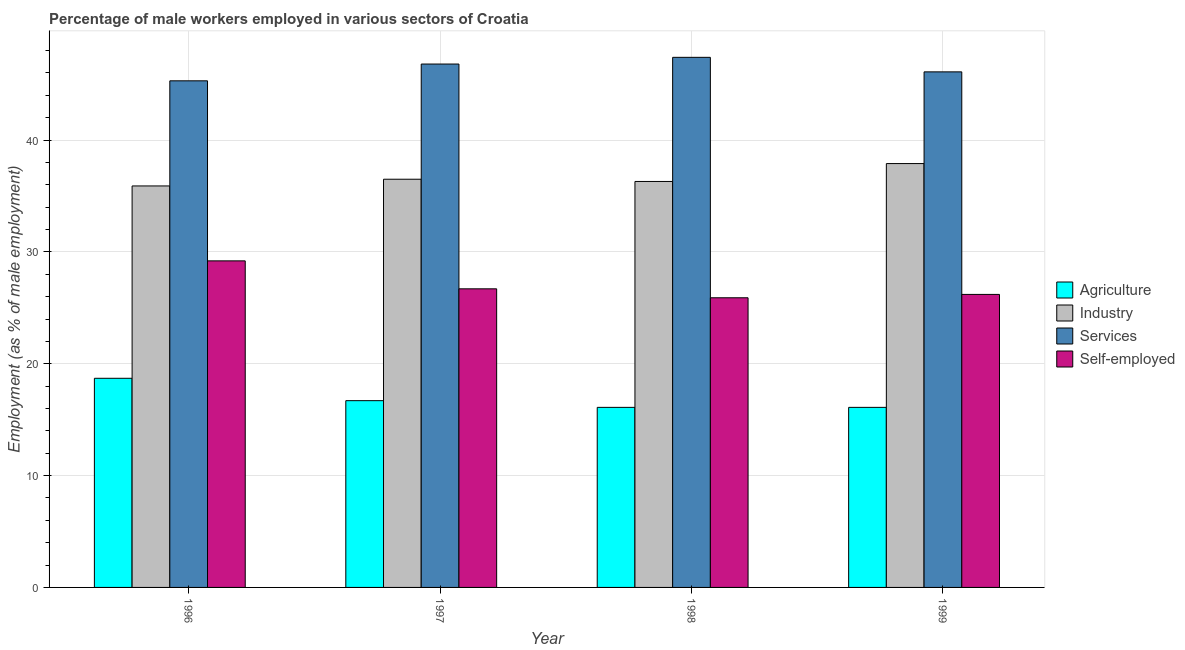How many groups of bars are there?
Your response must be concise. 4. Are the number of bars per tick equal to the number of legend labels?
Offer a very short reply. Yes. Are the number of bars on each tick of the X-axis equal?
Offer a terse response. Yes. How many bars are there on the 1st tick from the right?
Provide a short and direct response. 4. What is the percentage of male workers in services in 1999?
Make the answer very short. 46.1. Across all years, what is the maximum percentage of male workers in industry?
Offer a very short reply. 37.9. Across all years, what is the minimum percentage of male workers in agriculture?
Offer a terse response. 16.1. In which year was the percentage of male workers in agriculture maximum?
Ensure brevity in your answer.  1996. What is the total percentage of male workers in agriculture in the graph?
Ensure brevity in your answer.  67.6. What is the difference between the percentage of self employed male workers in 1998 and the percentage of male workers in agriculture in 1999?
Your answer should be very brief. -0.3. What is the average percentage of male workers in services per year?
Offer a terse response. 46.4. In the year 1998, what is the difference between the percentage of male workers in services and percentage of self employed male workers?
Your answer should be compact. 0. What is the ratio of the percentage of self employed male workers in 1998 to that in 1999?
Offer a very short reply. 0.99. Is the difference between the percentage of self employed male workers in 1998 and 1999 greater than the difference between the percentage of male workers in industry in 1998 and 1999?
Give a very brief answer. No. What is the difference between the highest and the second highest percentage of male workers in industry?
Your answer should be compact. 1.4. What is the difference between the highest and the lowest percentage of male workers in agriculture?
Your response must be concise. 2.6. Is the sum of the percentage of male workers in agriculture in 1997 and 1999 greater than the maximum percentage of male workers in services across all years?
Ensure brevity in your answer.  Yes. Is it the case that in every year, the sum of the percentage of male workers in services and percentage of male workers in agriculture is greater than the sum of percentage of self employed male workers and percentage of male workers in industry?
Your response must be concise. Yes. What does the 2nd bar from the left in 1997 represents?
Your response must be concise. Industry. What does the 4th bar from the right in 1998 represents?
Keep it short and to the point. Agriculture. Is it the case that in every year, the sum of the percentage of male workers in agriculture and percentage of male workers in industry is greater than the percentage of male workers in services?
Provide a succinct answer. Yes. How many years are there in the graph?
Provide a short and direct response. 4. What is the difference between two consecutive major ticks on the Y-axis?
Offer a very short reply. 10. Does the graph contain any zero values?
Give a very brief answer. No. How many legend labels are there?
Ensure brevity in your answer.  4. What is the title of the graph?
Offer a very short reply. Percentage of male workers employed in various sectors of Croatia. What is the label or title of the X-axis?
Keep it short and to the point. Year. What is the label or title of the Y-axis?
Provide a succinct answer. Employment (as % of male employment). What is the Employment (as % of male employment) in Agriculture in 1996?
Give a very brief answer. 18.7. What is the Employment (as % of male employment) of Industry in 1996?
Provide a short and direct response. 35.9. What is the Employment (as % of male employment) of Services in 1996?
Ensure brevity in your answer.  45.3. What is the Employment (as % of male employment) of Self-employed in 1996?
Your response must be concise. 29.2. What is the Employment (as % of male employment) in Agriculture in 1997?
Ensure brevity in your answer.  16.7. What is the Employment (as % of male employment) of Industry in 1997?
Your answer should be very brief. 36.5. What is the Employment (as % of male employment) in Services in 1997?
Give a very brief answer. 46.8. What is the Employment (as % of male employment) in Self-employed in 1997?
Offer a terse response. 26.7. What is the Employment (as % of male employment) of Agriculture in 1998?
Keep it short and to the point. 16.1. What is the Employment (as % of male employment) of Industry in 1998?
Provide a succinct answer. 36.3. What is the Employment (as % of male employment) in Services in 1998?
Offer a very short reply. 47.4. What is the Employment (as % of male employment) in Self-employed in 1998?
Your response must be concise. 25.9. What is the Employment (as % of male employment) in Agriculture in 1999?
Offer a very short reply. 16.1. What is the Employment (as % of male employment) in Industry in 1999?
Give a very brief answer. 37.9. What is the Employment (as % of male employment) in Services in 1999?
Give a very brief answer. 46.1. What is the Employment (as % of male employment) in Self-employed in 1999?
Your answer should be compact. 26.2. Across all years, what is the maximum Employment (as % of male employment) in Agriculture?
Your answer should be very brief. 18.7. Across all years, what is the maximum Employment (as % of male employment) in Industry?
Offer a very short reply. 37.9. Across all years, what is the maximum Employment (as % of male employment) of Services?
Provide a succinct answer. 47.4. Across all years, what is the maximum Employment (as % of male employment) of Self-employed?
Ensure brevity in your answer.  29.2. Across all years, what is the minimum Employment (as % of male employment) in Agriculture?
Your response must be concise. 16.1. Across all years, what is the minimum Employment (as % of male employment) in Industry?
Provide a succinct answer. 35.9. Across all years, what is the minimum Employment (as % of male employment) of Services?
Keep it short and to the point. 45.3. Across all years, what is the minimum Employment (as % of male employment) of Self-employed?
Keep it short and to the point. 25.9. What is the total Employment (as % of male employment) of Agriculture in the graph?
Ensure brevity in your answer.  67.6. What is the total Employment (as % of male employment) in Industry in the graph?
Make the answer very short. 146.6. What is the total Employment (as % of male employment) of Services in the graph?
Keep it short and to the point. 185.6. What is the total Employment (as % of male employment) of Self-employed in the graph?
Provide a succinct answer. 108. What is the difference between the Employment (as % of male employment) in Industry in 1996 and that in 1997?
Provide a succinct answer. -0.6. What is the difference between the Employment (as % of male employment) of Services in 1996 and that in 1997?
Provide a short and direct response. -1.5. What is the difference between the Employment (as % of male employment) of Self-employed in 1996 and that in 1997?
Provide a succinct answer. 2.5. What is the difference between the Employment (as % of male employment) in Agriculture in 1996 and that in 1999?
Give a very brief answer. 2.6. What is the difference between the Employment (as % of male employment) in Self-employed in 1996 and that in 1999?
Provide a short and direct response. 3. What is the difference between the Employment (as % of male employment) of Agriculture in 1997 and that in 1998?
Give a very brief answer. 0.6. What is the difference between the Employment (as % of male employment) of Industry in 1997 and that in 1998?
Offer a very short reply. 0.2. What is the difference between the Employment (as % of male employment) of Industry in 1997 and that in 1999?
Your response must be concise. -1.4. What is the difference between the Employment (as % of male employment) of Services in 1997 and that in 1999?
Provide a short and direct response. 0.7. What is the difference between the Employment (as % of male employment) of Agriculture in 1998 and that in 1999?
Your response must be concise. 0. What is the difference between the Employment (as % of male employment) of Industry in 1998 and that in 1999?
Make the answer very short. -1.6. What is the difference between the Employment (as % of male employment) in Agriculture in 1996 and the Employment (as % of male employment) in Industry in 1997?
Offer a very short reply. -17.8. What is the difference between the Employment (as % of male employment) in Agriculture in 1996 and the Employment (as % of male employment) in Services in 1997?
Offer a very short reply. -28.1. What is the difference between the Employment (as % of male employment) of Agriculture in 1996 and the Employment (as % of male employment) of Self-employed in 1997?
Offer a terse response. -8. What is the difference between the Employment (as % of male employment) of Industry in 1996 and the Employment (as % of male employment) of Self-employed in 1997?
Your answer should be compact. 9.2. What is the difference between the Employment (as % of male employment) in Agriculture in 1996 and the Employment (as % of male employment) in Industry in 1998?
Your response must be concise. -17.6. What is the difference between the Employment (as % of male employment) in Agriculture in 1996 and the Employment (as % of male employment) in Services in 1998?
Your answer should be compact. -28.7. What is the difference between the Employment (as % of male employment) in Agriculture in 1996 and the Employment (as % of male employment) in Self-employed in 1998?
Offer a terse response. -7.2. What is the difference between the Employment (as % of male employment) of Industry in 1996 and the Employment (as % of male employment) of Services in 1998?
Your response must be concise. -11.5. What is the difference between the Employment (as % of male employment) of Industry in 1996 and the Employment (as % of male employment) of Self-employed in 1998?
Your answer should be compact. 10. What is the difference between the Employment (as % of male employment) of Services in 1996 and the Employment (as % of male employment) of Self-employed in 1998?
Offer a very short reply. 19.4. What is the difference between the Employment (as % of male employment) of Agriculture in 1996 and the Employment (as % of male employment) of Industry in 1999?
Give a very brief answer. -19.2. What is the difference between the Employment (as % of male employment) of Agriculture in 1996 and the Employment (as % of male employment) of Services in 1999?
Ensure brevity in your answer.  -27.4. What is the difference between the Employment (as % of male employment) in Agriculture in 1996 and the Employment (as % of male employment) in Self-employed in 1999?
Provide a short and direct response. -7.5. What is the difference between the Employment (as % of male employment) of Industry in 1996 and the Employment (as % of male employment) of Services in 1999?
Your response must be concise. -10.2. What is the difference between the Employment (as % of male employment) in Services in 1996 and the Employment (as % of male employment) in Self-employed in 1999?
Your answer should be very brief. 19.1. What is the difference between the Employment (as % of male employment) in Agriculture in 1997 and the Employment (as % of male employment) in Industry in 1998?
Ensure brevity in your answer.  -19.6. What is the difference between the Employment (as % of male employment) of Agriculture in 1997 and the Employment (as % of male employment) of Services in 1998?
Offer a very short reply. -30.7. What is the difference between the Employment (as % of male employment) of Industry in 1997 and the Employment (as % of male employment) of Services in 1998?
Offer a terse response. -10.9. What is the difference between the Employment (as % of male employment) in Industry in 1997 and the Employment (as % of male employment) in Self-employed in 1998?
Your answer should be very brief. 10.6. What is the difference between the Employment (as % of male employment) of Services in 1997 and the Employment (as % of male employment) of Self-employed in 1998?
Provide a succinct answer. 20.9. What is the difference between the Employment (as % of male employment) in Agriculture in 1997 and the Employment (as % of male employment) in Industry in 1999?
Provide a short and direct response. -21.2. What is the difference between the Employment (as % of male employment) of Agriculture in 1997 and the Employment (as % of male employment) of Services in 1999?
Your response must be concise. -29.4. What is the difference between the Employment (as % of male employment) of Services in 1997 and the Employment (as % of male employment) of Self-employed in 1999?
Make the answer very short. 20.6. What is the difference between the Employment (as % of male employment) of Agriculture in 1998 and the Employment (as % of male employment) of Industry in 1999?
Your answer should be compact. -21.8. What is the difference between the Employment (as % of male employment) of Agriculture in 1998 and the Employment (as % of male employment) of Services in 1999?
Your response must be concise. -30. What is the difference between the Employment (as % of male employment) in Agriculture in 1998 and the Employment (as % of male employment) in Self-employed in 1999?
Offer a very short reply. -10.1. What is the difference between the Employment (as % of male employment) of Services in 1998 and the Employment (as % of male employment) of Self-employed in 1999?
Make the answer very short. 21.2. What is the average Employment (as % of male employment) in Industry per year?
Ensure brevity in your answer.  36.65. What is the average Employment (as % of male employment) of Services per year?
Provide a succinct answer. 46.4. What is the average Employment (as % of male employment) of Self-employed per year?
Offer a terse response. 27. In the year 1996, what is the difference between the Employment (as % of male employment) in Agriculture and Employment (as % of male employment) in Industry?
Offer a terse response. -17.2. In the year 1996, what is the difference between the Employment (as % of male employment) of Agriculture and Employment (as % of male employment) of Services?
Offer a terse response. -26.6. In the year 1996, what is the difference between the Employment (as % of male employment) of Agriculture and Employment (as % of male employment) of Self-employed?
Offer a terse response. -10.5. In the year 1996, what is the difference between the Employment (as % of male employment) in Industry and Employment (as % of male employment) in Services?
Your answer should be compact. -9.4. In the year 1997, what is the difference between the Employment (as % of male employment) of Agriculture and Employment (as % of male employment) of Industry?
Offer a very short reply. -19.8. In the year 1997, what is the difference between the Employment (as % of male employment) in Agriculture and Employment (as % of male employment) in Services?
Keep it short and to the point. -30.1. In the year 1997, what is the difference between the Employment (as % of male employment) in Agriculture and Employment (as % of male employment) in Self-employed?
Your answer should be compact. -10. In the year 1997, what is the difference between the Employment (as % of male employment) in Industry and Employment (as % of male employment) in Services?
Give a very brief answer. -10.3. In the year 1997, what is the difference between the Employment (as % of male employment) of Services and Employment (as % of male employment) of Self-employed?
Provide a short and direct response. 20.1. In the year 1998, what is the difference between the Employment (as % of male employment) of Agriculture and Employment (as % of male employment) of Industry?
Provide a short and direct response. -20.2. In the year 1998, what is the difference between the Employment (as % of male employment) in Agriculture and Employment (as % of male employment) in Services?
Give a very brief answer. -31.3. In the year 1998, what is the difference between the Employment (as % of male employment) of Industry and Employment (as % of male employment) of Services?
Provide a short and direct response. -11.1. In the year 1998, what is the difference between the Employment (as % of male employment) in Industry and Employment (as % of male employment) in Self-employed?
Make the answer very short. 10.4. In the year 1998, what is the difference between the Employment (as % of male employment) in Services and Employment (as % of male employment) in Self-employed?
Your answer should be very brief. 21.5. In the year 1999, what is the difference between the Employment (as % of male employment) of Agriculture and Employment (as % of male employment) of Industry?
Give a very brief answer. -21.8. In the year 1999, what is the difference between the Employment (as % of male employment) of Agriculture and Employment (as % of male employment) of Services?
Provide a succinct answer. -30. In the year 1999, what is the difference between the Employment (as % of male employment) in Industry and Employment (as % of male employment) in Services?
Ensure brevity in your answer.  -8.2. In the year 1999, what is the difference between the Employment (as % of male employment) of Industry and Employment (as % of male employment) of Self-employed?
Offer a very short reply. 11.7. What is the ratio of the Employment (as % of male employment) in Agriculture in 1996 to that in 1997?
Ensure brevity in your answer.  1.12. What is the ratio of the Employment (as % of male employment) in Industry in 1996 to that in 1997?
Your response must be concise. 0.98. What is the ratio of the Employment (as % of male employment) in Services in 1996 to that in 1997?
Provide a succinct answer. 0.97. What is the ratio of the Employment (as % of male employment) of Self-employed in 1996 to that in 1997?
Provide a short and direct response. 1.09. What is the ratio of the Employment (as % of male employment) of Agriculture in 1996 to that in 1998?
Offer a very short reply. 1.16. What is the ratio of the Employment (as % of male employment) in Industry in 1996 to that in 1998?
Make the answer very short. 0.99. What is the ratio of the Employment (as % of male employment) in Services in 1996 to that in 1998?
Keep it short and to the point. 0.96. What is the ratio of the Employment (as % of male employment) in Self-employed in 1996 to that in 1998?
Offer a very short reply. 1.13. What is the ratio of the Employment (as % of male employment) in Agriculture in 1996 to that in 1999?
Your response must be concise. 1.16. What is the ratio of the Employment (as % of male employment) in Industry in 1996 to that in 1999?
Give a very brief answer. 0.95. What is the ratio of the Employment (as % of male employment) in Services in 1996 to that in 1999?
Your answer should be compact. 0.98. What is the ratio of the Employment (as % of male employment) of Self-employed in 1996 to that in 1999?
Offer a very short reply. 1.11. What is the ratio of the Employment (as % of male employment) of Agriculture in 1997 to that in 1998?
Provide a succinct answer. 1.04. What is the ratio of the Employment (as % of male employment) in Services in 1997 to that in 1998?
Your answer should be very brief. 0.99. What is the ratio of the Employment (as % of male employment) in Self-employed in 1997 to that in 1998?
Provide a succinct answer. 1.03. What is the ratio of the Employment (as % of male employment) in Agriculture in 1997 to that in 1999?
Ensure brevity in your answer.  1.04. What is the ratio of the Employment (as % of male employment) in Industry in 1997 to that in 1999?
Ensure brevity in your answer.  0.96. What is the ratio of the Employment (as % of male employment) of Services in 1997 to that in 1999?
Your response must be concise. 1.02. What is the ratio of the Employment (as % of male employment) of Self-employed in 1997 to that in 1999?
Keep it short and to the point. 1.02. What is the ratio of the Employment (as % of male employment) of Industry in 1998 to that in 1999?
Your answer should be compact. 0.96. What is the ratio of the Employment (as % of male employment) of Services in 1998 to that in 1999?
Provide a short and direct response. 1.03. What is the difference between the highest and the second highest Employment (as % of male employment) in Agriculture?
Ensure brevity in your answer.  2. What is the difference between the highest and the second highest Employment (as % of male employment) in Industry?
Keep it short and to the point. 1.4. What is the difference between the highest and the second highest Employment (as % of male employment) in Services?
Your answer should be very brief. 0.6. What is the difference between the highest and the lowest Employment (as % of male employment) of Self-employed?
Your response must be concise. 3.3. 